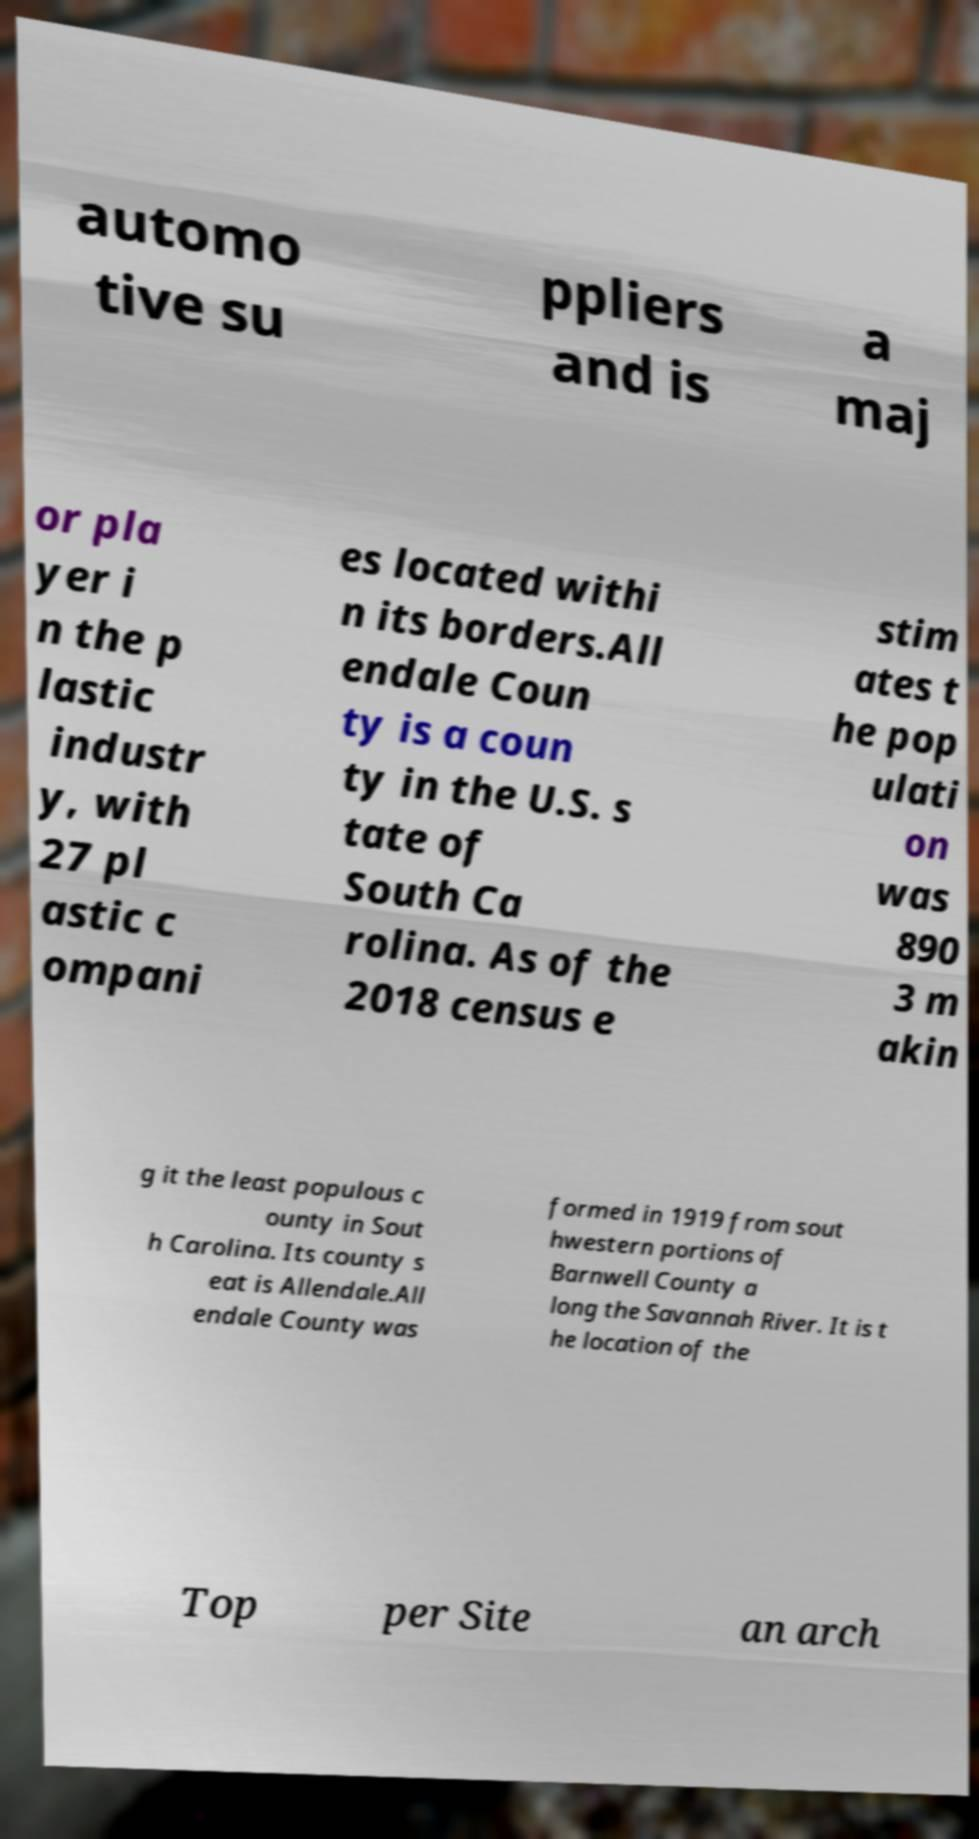Can you read and provide the text displayed in the image?This photo seems to have some interesting text. Can you extract and type it out for me? automo tive su ppliers and is a maj or pla yer i n the p lastic industr y, with 27 pl astic c ompani es located withi n its borders.All endale Coun ty is a coun ty in the U.S. s tate of South Ca rolina. As of the 2018 census e stim ates t he pop ulati on was 890 3 m akin g it the least populous c ounty in Sout h Carolina. Its county s eat is Allendale.All endale County was formed in 1919 from sout hwestern portions of Barnwell County a long the Savannah River. It is t he location of the Top per Site an arch 